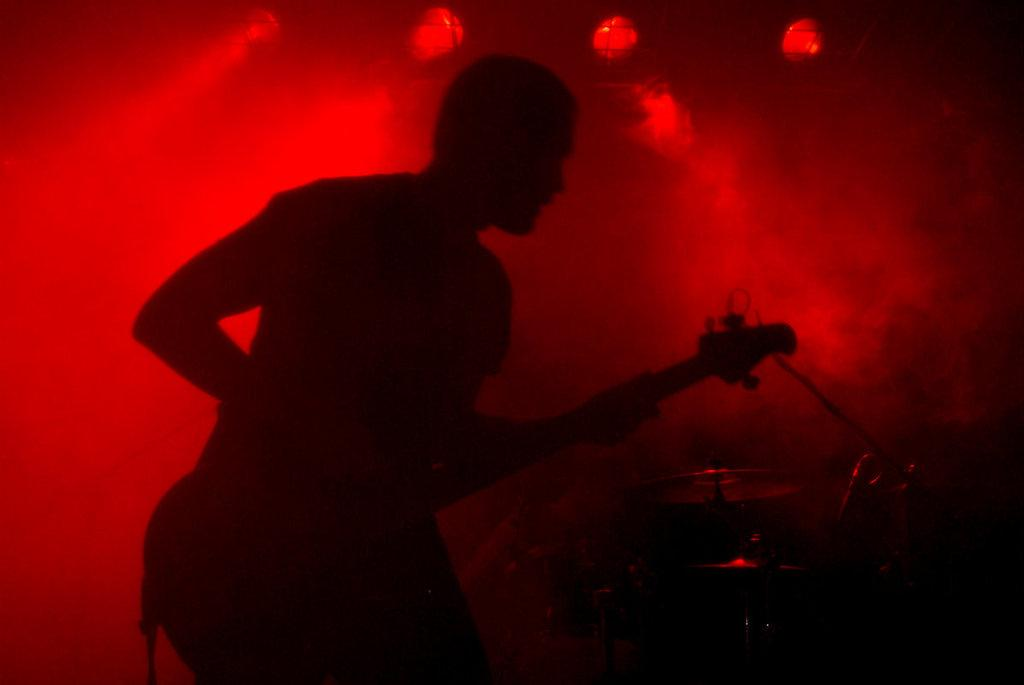What is the main subject of the image? There is a person in the image. What is the person holding in the image? The person is holding a guitar. What is the person doing with the guitar? The person is playing the guitar. What color is the background of the image? The background color is red. Are there any cobwebs visible in the image? There is no mention of cobwebs in the provided facts, so we cannot determine if any are present in the image. 